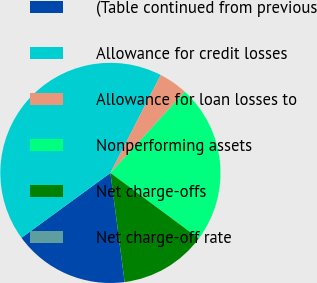Convert chart to OTSL. <chart><loc_0><loc_0><loc_500><loc_500><pie_chart><fcel>(Table continued from previous<fcel>Allowance for credit losses<fcel>Allowance for loan losses to<fcel>Nonperforming assets<fcel>Net charge-offs<fcel>Net charge-off rate<nl><fcel>17.03%<fcel>42.58%<fcel>4.26%<fcel>23.35%<fcel>12.78%<fcel>0.0%<nl></chart> 